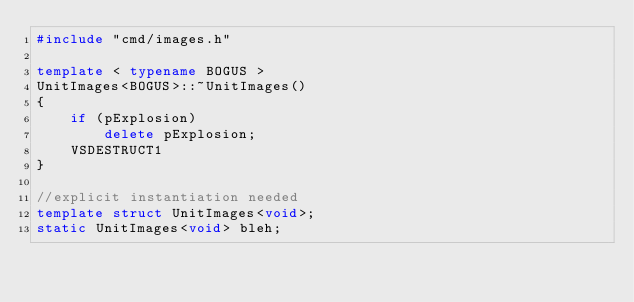Convert code to text. <code><loc_0><loc_0><loc_500><loc_500><_C++_>#include "cmd/images.h"

template < typename BOGUS >
UnitImages<BOGUS>::~UnitImages()
{
    if (pExplosion)
        delete pExplosion;
    VSDESTRUCT1
}

//explicit instantiation needed
template struct UnitImages<void>;
static UnitImages<void> bleh;</code> 